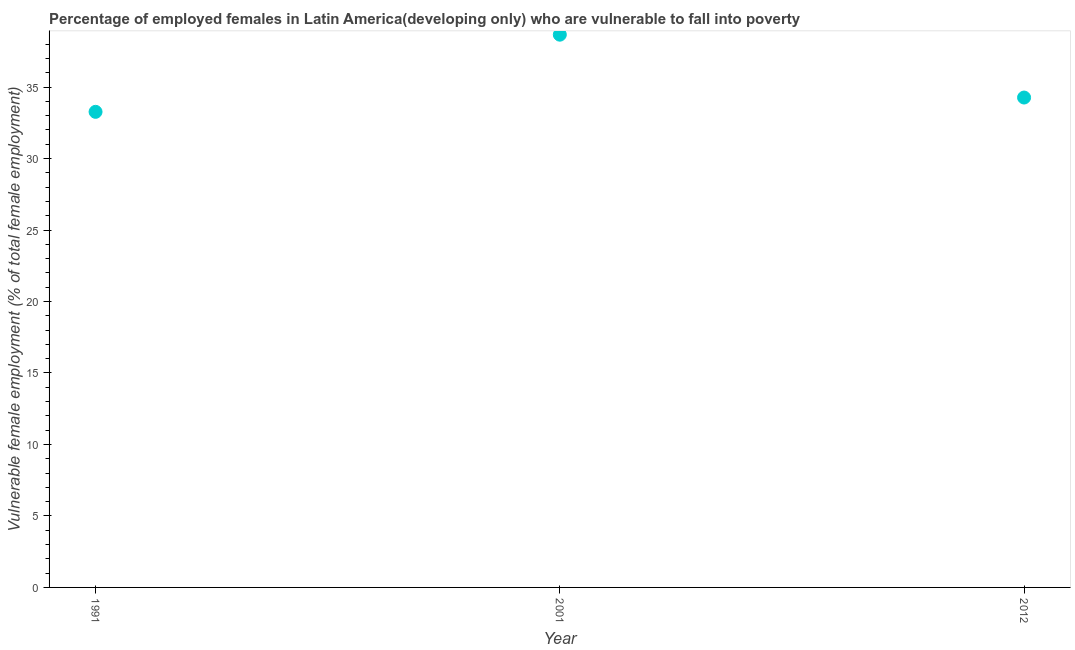What is the percentage of employed females who are vulnerable to fall into poverty in 2001?
Your response must be concise. 38.66. Across all years, what is the maximum percentage of employed females who are vulnerable to fall into poverty?
Provide a short and direct response. 38.66. Across all years, what is the minimum percentage of employed females who are vulnerable to fall into poverty?
Provide a succinct answer. 33.27. In which year was the percentage of employed females who are vulnerable to fall into poverty maximum?
Provide a short and direct response. 2001. In which year was the percentage of employed females who are vulnerable to fall into poverty minimum?
Your answer should be compact. 1991. What is the sum of the percentage of employed females who are vulnerable to fall into poverty?
Ensure brevity in your answer.  106.19. What is the difference between the percentage of employed females who are vulnerable to fall into poverty in 1991 and 2001?
Provide a succinct answer. -5.4. What is the average percentage of employed females who are vulnerable to fall into poverty per year?
Make the answer very short. 35.4. What is the median percentage of employed females who are vulnerable to fall into poverty?
Provide a succinct answer. 34.27. Do a majority of the years between 2001 and 1991 (inclusive) have percentage of employed females who are vulnerable to fall into poverty greater than 35 %?
Your answer should be compact. No. What is the ratio of the percentage of employed females who are vulnerable to fall into poverty in 1991 to that in 2001?
Your answer should be very brief. 0.86. Is the percentage of employed females who are vulnerable to fall into poverty in 1991 less than that in 2001?
Your response must be concise. Yes. What is the difference between the highest and the second highest percentage of employed females who are vulnerable to fall into poverty?
Offer a terse response. 4.4. What is the difference between the highest and the lowest percentage of employed females who are vulnerable to fall into poverty?
Provide a short and direct response. 5.4. How many dotlines are there?
Your answer should be very brief. 1. How many years are there in the graph?
Provide a short and direct response. 3. What is the difference between two consecutive major ticks on the Y-axis?
Your answer should be compact. 5. Does the graph contain grids?
Provide a short and direct response. No. What is the title of the graph?
Make the answer very short. Percentage of employed females in Latin America(developing only) who are vulnerable to fall into poverty. What is the label or title of the Y-axis?
Provide a succinct answer. Vulnerable female employment (% of total female employment). What is the Vulnerable female employment (% of total female employment) in 1991?
Offer a very short reply. 33.27. What is the Vulnerable female employment (% of total female employment) in 2001?
Make the answer very short. 38.66. What is the Vulnerable female employment (% of total female employment) in 2012?
Ensure brevity in your answer.  34.27. What is the difference between the Vulnerable female employment (% of total female employment) in 1991 and 2001?
Your response must be concise. -5.4. What is the difference between the Vulnerable female employment (% of total female employment) in 1991 and 2012?
Your answer should be very brief. -1. What is the difference between the Vulnerable female employment (% of total female employment) in 2001 and 2012?
Your answer should be very brief. 4.4. What is the ratio of the Vulnerable female employment (% of total female employment) in 1991 to that in 2001?
Provide a short and direct response. 0.86. What is the ratio of the Vulnerable female employment (% of total female employment) in 1991 to that in 2012?
Provide a succinct answer. 0.97. What is the ratio of the Vulnerable female employment (% of total female employment) in 2001 to that in 2012?
Give a very brief answer. 1.13. 